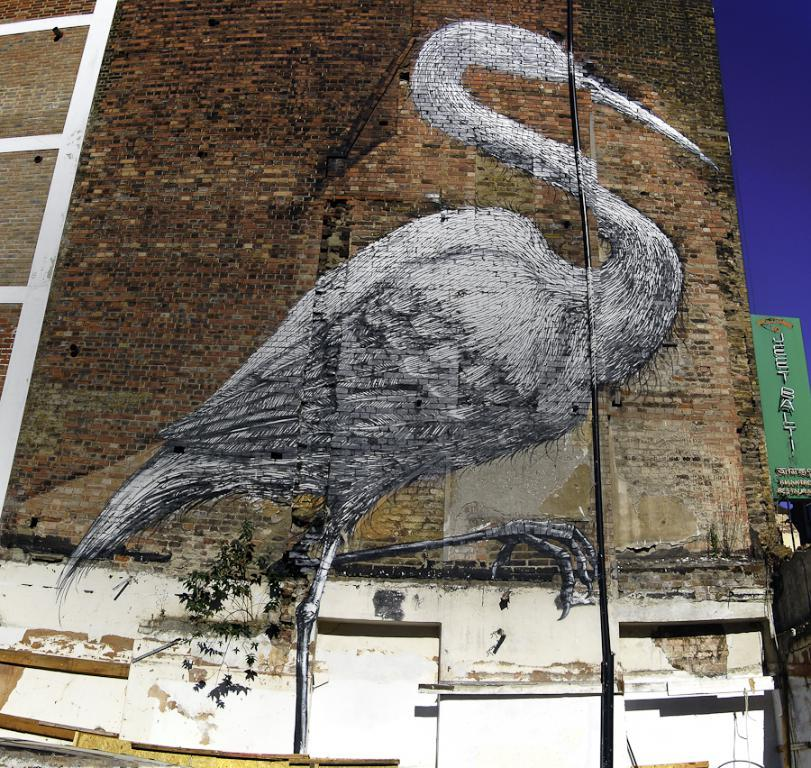What type of structure is visible in the image? There is a brick wall in the image. What is depicted on the brick wall? There is a painting of a crane on the wall. What can be seen on the right side of the wall? There is a board with writing on the right side of the wall. What is visible in the background of the image? The sky is visible in the background of the image. How many flowers are growing on the arm of the crane in the image? There are no flowers or arms visible in the image; it features a painting of a crane on a brick wall. 